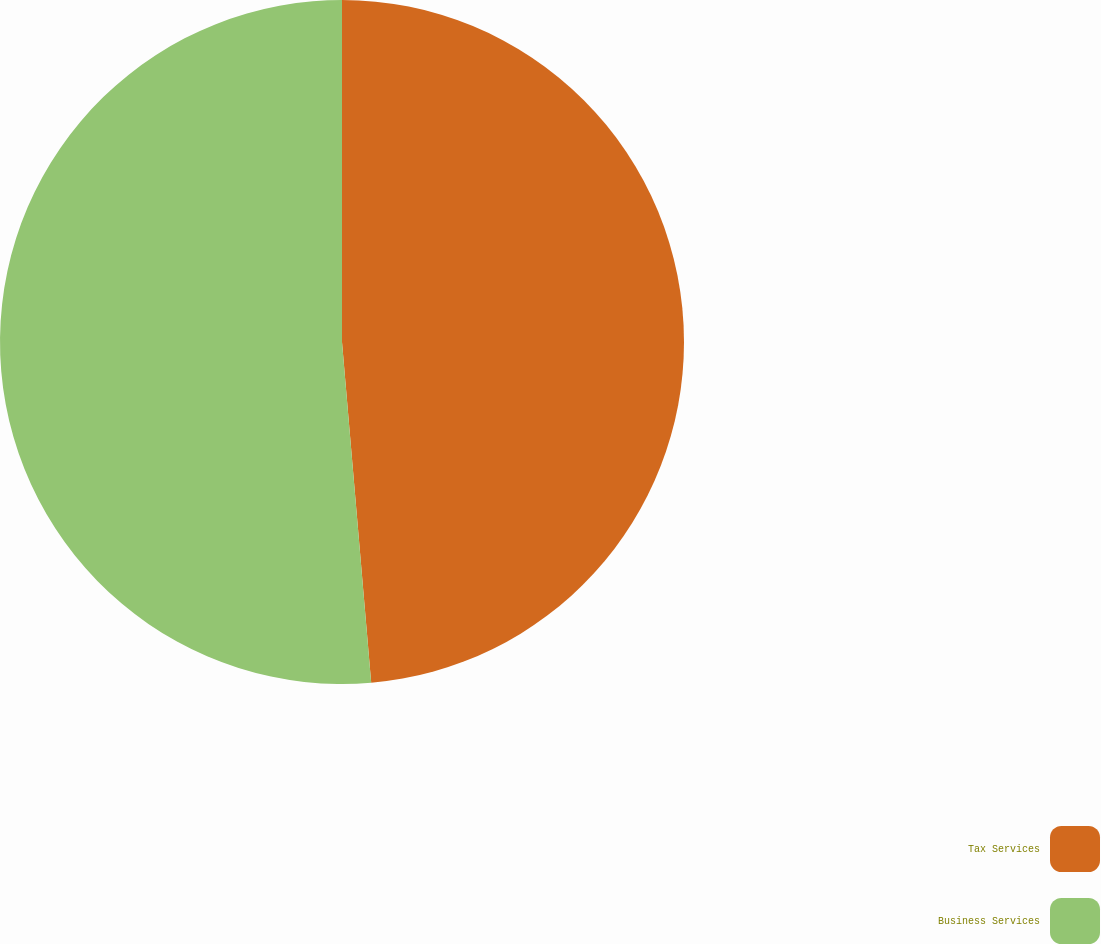Convert chart. <chart><loc_0><loc_0><loc_500><loc_500><pie_chart><fcel>Tax Services<fcel>Business Services<nl><fcel>48.64%<fcel>51.36%<nl></chart> 